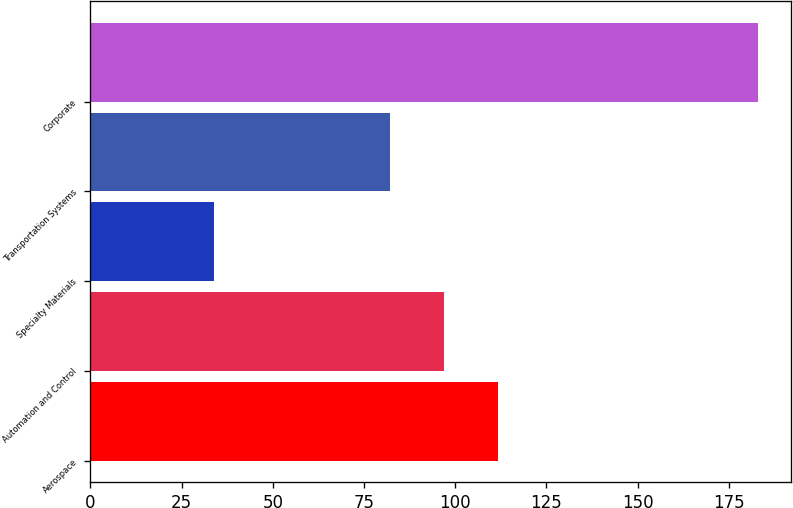<chart> <loc_0><loc_0><loc_500><loc_500><bar_chart><fcel>Aerospace<fcel>Automation and Control<fcel>Specialty Materials<fcel>Transportation Systems<fcel>Corporate<nl><fcel>111.8<fcel>96.9<fcel>34<fcel>82<fcel>183<nl></chart> 